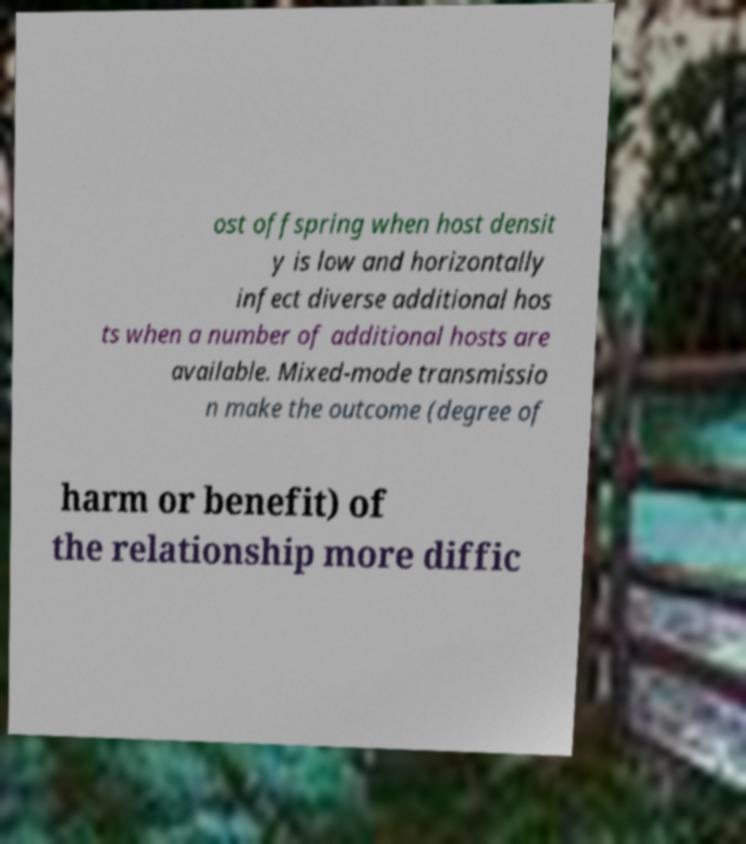Could you assist in decoding the text presented in this image and type it out clearly? ost offspring when host densit y is low and horizontally infect diverse additional hos ts when a number of additional hosts are available. Mixed-mode transmissio n make the outcome (degree of harm or benefit) of the relationship more diffic 